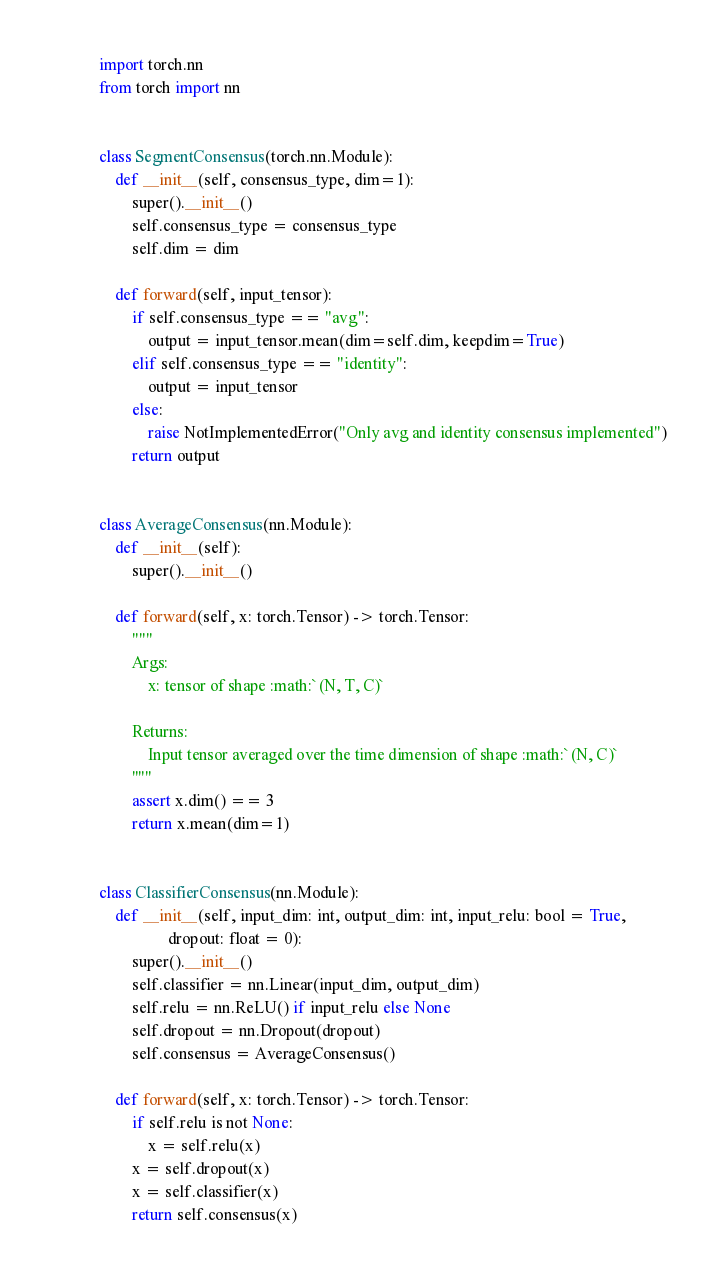<code> <loc_0><loc_0><loc_500><loc_500><_Python_>import torch.nn
from torch import nn


class SegmentConsensus(torch.nn.Module):
    def __init__(self, consensus_type, dim=1):
        super().__init__()
        self.consensus_type = consensus_type
        self.dim = dim

    def forward(self, input_tensor):
        if self.consensus_type == "avg":
            output = input_tensor.mean(dim=self.dim, keepdim=True)
        elif self.consensus_type == "identity":
            output = input_tensor
        else:
            raise NotImplementedError("Only avg and identity consensus implemented")
        return output


class AverageConsensus(nn.Module):
    def __init__(self):
        super().__init__()

    def forward(self, x: torch.Tensor) -> torch.Tensor:
        """
        Args:
            x: tensor of shape :math:`(N, T, C)`

        Returns:
            Input tensor averaged over the time dimension of shape :math:`(N, C)`
        """
        assert x.dim() == 3
        return x.mean(dim=1)


class ClassifierConsensus(nn.Module):
    def __init__(self, input_dim: int, output_dim: int, input_relu: bool = True,
                 dropout: float = 0):
        super().__init__()
        self.classifier = nn.Linear(input_dim, output_dim)
        self.relu = nn.ReLU() if input_relu else None
        self.dropout = nn.Dropout(dropout)
        self.consensus = AverageConsensus()

    def forward(self, x: torch.Tensor) -> torch.Tensor:
        if self.relu is not None:
            x = self.relu(x)
        x = self.dropout(x)
        x = self.classifier(x)
        return self.consensus(x)


</code> 